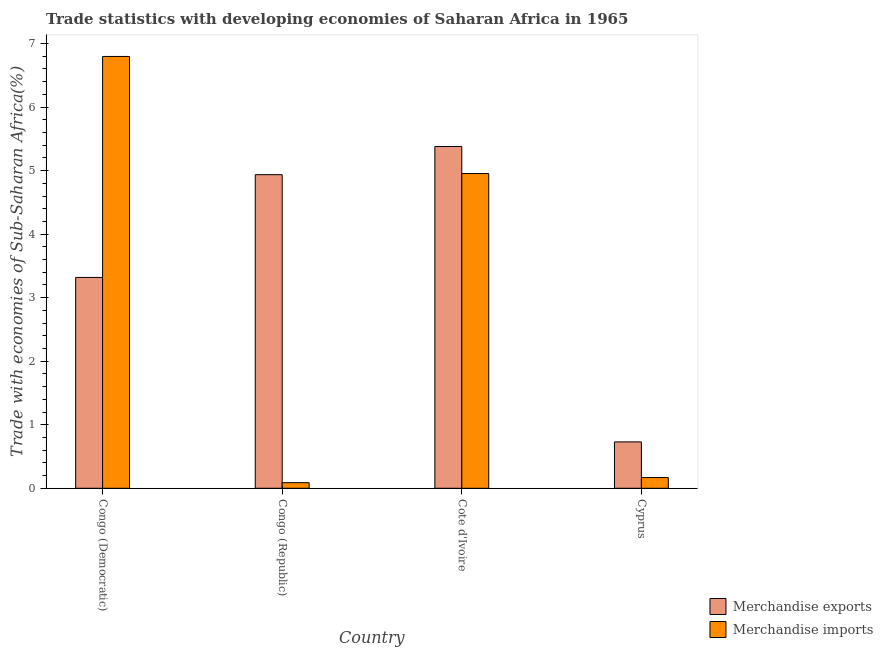How many groups of bars are there?
Offer a terse response. 4. Are the number of bars per tick equal to the number of legend labels?
Make the answer very short. Yes. Are the number of bars on each tick of the X-axis equal?
Make the answer very short. Yes. What is the label of the 1st group of bars from the left?
Provide a succinct answer. Congo (Democratic). What is the merchandise exports in Cote d'Ivoire?
Give a very brief answer. 5.38. Across all countries, what is the maximum merchandise imports?
Provide a succinct answer. 6.8. Across all countries, what is the minimum merchandise exports?
Provide a succinct answer. 0.73. In which country was the merchandise exports maximum?
Offer a very short reply. Cote d'Ivoire. In which country was the merchandise imports minimum?
Make the answer very short. Congo (Republic). What is the total merchandise imports in the graph?
Your answer should be very brief. 12.01. What is the difference between the merchandise exports in Congo (Democratic) and that in Cyprus?
Offer a very short reply. 2.59. What is the difference between the merchandise imports in Congo (Republic) and the merchandise exports in Congo (Democratic)?
Provide a succinct answer. -3.23. What is the average merchandise exports per country?
Make the answer very short. 3.59. What is the difference between the merchandise imports and merchandise exports in Cote d'Ivoire?
Your answer should be compact. -0.43. In how many countries, is the merchandise imports greater than 3.4 %?
Provide a short and direct response. 2. What is the ratio of the merchandise exports in Cote d'Ivoire to that in Cyprus?
Your answer should be very brief. 7.37. Is the difference between the merchandise exports in Cote d'Ivoire and Cyprus greater than the difference between the merchandise imports in Cote d'Ivoire and Cyprus?
Your response must be concise. No. What is the difference between the highest and the second highest merchandise imports?
Provide a succinct answer. 1.84. What is the difference between the highest and the lowest merchandise exports?
Offer a terse response. 4.65. Is the sum of the merchandise exports in Cote d'Ivoire and Cyprus greater than the maximum merchandise imports across all countries?
Your answer should be very brief. No. What does the 1st bar from the right in Cote d'Ivoire represents?
Give a very brief answer. Merchandise imports. How many countries are there in the graph?
Your answer should be very brief. 4. Are the values on the major ticks of Y-axis written in scientific E-notation?
Ensure brevity in your answer.  No. Where does the legend appear in the graph?
Your answer should be compact. Bottom right. What is the title of the graph?
Keep it short and to the point. Trade statistics with developing economies of Saharan Africa in 1965. What is the label or title of the X-axis?
Your answer should be compact. Country. What is the label or title of the Y-axis?
Make the answer very short. Trade with economies of Sub-Saharan Africa(%). What is the Trade with economies of Sub-Saharan Africa(%) in Merchandise exports in Congo (Democratic)?
Ensure brevity in your answer.  3.32. What is the Trade with economies of Sub-Saharan Africa(%) in Merchandise imports in Congo (Democratic)?
Offer a terse response. 6.8. What is the Trade with economies of Sub-Saharan Africa(%) of Merchandise exports in Congo (Republic)?
Give a very brief answer. 4.94. What is the Trade with economies of Sub-Saharan Africa(%) in Merchandise imports in Congo (Republic)?
Provide a succinct answer. 0.09. What is the Trade with economies of Sub-Saharan Africa(%) of Merchandise exports in Cote d'Ivoire?
Your answer should be compact. 5.38. What is the Trade with economies of Sub-Saharan Africa(%) in Merchandise imports in Cote d'Ivoire?
Keep it short and to the point. 4.95. What is the Trade with economies of Sub-Saharan Africa(%) of Merchandise exports in Cyprus?
Offer a terse response. 0.73. What is the Trade with economies of Sub-Saharan Africa(%) in Merchandise imports in Cyprus?
Ensure brevity in your answer.  0.17. Across all countries, what is the maximum Trade with economies of Sub-Saharan Africa(%) in Merchandise exports?
Ensure brevity in your answer.  5.38. Across all countries, what is the maximum Trade with economies of Sub-Saharan Africa(%) of Merchandise imports?
Your answer should be compact. 6.8. Across all countries, what is the minimum Trade with economies of Sub-Saharan Africa(%) in Merchandise exports?
Give a very brief answer. 0.73. Across all countries, what is the minimum Trade with economies of Sub-Saharan Africa(%) in Merchandise imports?
Ensure brevity in your answer.  0.09. What is the total Trade with economies of Sub-Saharan Africa(%) of Merchandise exports in the graph?
Your answer should be compact. 14.36. What is the total Trade with economies of Sub-Saharan Africa(%) in Merchandise imports in the graph?
Your response must be concise. 12.01. What is the difference between the Trade with economies of Sub-Saharan Africa(%) in Merchandise exports in Congo (Democratic) and that in Congo (Republic)?
Your answer should be very brief. -1.62. What is the difference between the Trade with economies of Sub-Saharan Africa(%) of Merchandise imports in Congo (Democratic) and that in Congo (Republic)?
Your answer should be very brief. 6.71. What is the difference between the Trade with economies of Sub-Saharan Africa(%) of Merchandise exports in Congo (Democratic) and that in Cote d'Ivoire?
Provide a succinct answer. -2.06. What is the difference between the Trade with economies of Sub-Saharan Africa(%) of Merchandise imports in Congo (Democratic) and that in Cote d'Ivoire?
Your answer should be compact. 1.84. What is the difference between the Trade with economies of Sub-Saharan Africa(%) in Merchandise exports in Congo (Democratic) and that in Cyprus?
Your answer should be very brief. 2.59. What is the difference between the Trade with economies of Sub-Saharan Africa(%) in Merchandise imports in Congo (Democratic) and that in Cyprus?
Your response must be concise. 6.63. What is the difference between the Trade with economies of Sub-Saharan Africa(%) of Merchandise exports in Congo (Republic) and that in Cote d'Ivoire?
Give a very brief answer. -0.44. What is the difference between the Trade with economies of Sub-Saharan Africa(%) in Merchandise imports in Congo (Republic) and that in Cote d'Ivoire?
Provide a succinct answer. -4.87. What is the difference between the Trade with economies of Sub-Saharan Africa(%) in Merchandise exports in Congo (Republic) and that in Cyprus?
Ensure brevity in your answer.  4.21. What is the difference between the Trade with economies of Sub-Saharan Africa(%) in Merchandise imports in Congo (Republic) and that in Cyprus?
Give a very brief answer. -0.08. What is the difference between the Trade with economies of Sub-Saharan Africa(%) in Merchandise exports in Cote d'Ivoire and that in Cyprus?
Your response must be concise. 4.65. What is the difference between the Trade with economies of Sub-Saharan Africa(%) in Merchandise imports in Cote d'Ivoire and that in Cyprus?
Make the answer very short. 4.79. What is the difference between the Trade with economies of Sub-Saharan Africa(%) of Merchandise exports in Congo (Democratic) and the Trade with economies of Sub-Saharan Africa(%) of Merchandise imports in Congo (Republic)?
Make the answer very short. 3.23. What is the difference between the Trade with economies of Sub-Saharan Africa(%) in Merchandise exports in Congo (Democratic) and the Trade with economies of Sub-Saharan Africa(%) in Merchandise imports in Cote d'Ivoire?
Your answer should be compact. -1.64. What is the difference between the Trade with economies of Sub-Saharan Africa(%) in Merchandise exports in Congo (Democratic) and the Trade with economies of Sub-Saharan Africa(%) in Merchandise imports in Cyprus?
Provide a short and direct response. 3.15. What is the difference between the Trade with economies of Sub-Saharan Africa(%) in Merchandise exports in Congo (Republic) and the Trade with economies of Sub-Saharan Africa(%) in Merchandise imports in Cote d'Ivoire?
Keep it short and to the point. -0.02. What is the difference between the Trade with economies of Sub-Saharan Africa(%) in Merchandise exports in Congo (Republic) and the Trade with economies of Sub-Saharan Africa(%) in Merchandise imports in Cyprus?
Provide a short and direct response. 4.77. What is the difference between the Trade with economies of Sub-Saharan Africa(%) in Merchandise exports in Cote d'Ivoire and the Trade with economies of Sub-Saharan Africa(%) in Merchandise imports in Cyprus?
Provide a short and direct response. 5.21. What is the average Trade with economies of Sub-Saharan Africa(%) in Merchandise exports per country?
Give a very brief answer. 3.59. What is the average Trade with economies of Sub-Saharan Africa(%) in Merchandise imports per country?
Provide a succinct answer. 3. What is the difference between the Trade with economies of Sub-Saharan Africa(%) of Merchandise exports and Trade with economies of Sub-Saharan Africa(%) of Merchandise imports in Congo (Democratic)?
Offer a terse response. -3.48. What is the difference between the Trade with economies of Sub-Saharan Africa(%) of Merchandise exports and Trade with economies of Sub-Saharan Africa(%) of Merchandise imports in Congo (Republic)?
Make the answer very short. 4.85. What is the difference between the Trade with economies of Sub-Saharan Africa(%) of Merchandise exports and Trade with economies of Sub-Saharan Africa(%) of Merchandise imports in Cote d'Ivoire?
Your response must be concise. 0.43. What is the difference between the Trade with economies of Sub-Saharan Africa(%) in Merchandise exports and Trade with economies of Sub-Saharan Africa(%) in Merchandise imports in Cyprus?
Your answer should be compact. 0.56. What is the ratio of the Trade with economies of Sub-Saharan Africa(%) of Merchandise exports in Congo (Democratic) to that in Congo (Republic)?
Ensure brevity in your answer.  0.67. What is the ratio of the Trade with economies of Sub-Saharan Africa(%) in Merchandise imports in Congo (Democratic) to that in Congo (Republic)?
Make the answer very short. 76.81. What is the ratio of the Trade with economies of Sub-Saharan Africa(%) of Merchandise exports in Congo (Democratic) to that in Cote d'Ivoire?
Provide a short and direct response. 0.62. What is the ratio of the Trade with economies of Sub-Saharan Africa(%) in Merchandise imports in Congo (Democratic) to that in Cote d'Ivoire?
Keep it short and to the point. 1.37. What is the ratio of the Trade with economies of Sub-Saharan Africa(%) in Merchandise exports in Congo (Democratic) to that in Cyprus?
Offer a terse response. 4.55. What is the ratio of the Trade with economies of Sub-Saharan Africa(%) of Merchandise imports in Congo (Democratic) to that in Cyprus?
Your answer should be compact. 40.35. What is the ratio of the Trade with economies of Sub-Saharan Africa(%) of Merchandise exports in Congo (Republic) to that in Cote d'Ivoire?
Your response must be concise. 0.92. What is the ratio of the Trade with economies of Sub-Saharan Africa(%) of Merchandise imports in Congo (Republic) to that in Cote d'Ivoire?
Provide a succinct answer. 0.02. What is the ratio of the Trade with economies of Sub-Saharan Africa(%) in Merchandise exports in Congo (Republic) to that in Cyprus?
Offer a very short reply. 6.76. What is the ratio of the Trade with economies of Sub-Saharan Africa(%) of Merchandise imports in Congo (Republic) to that in Cyprus?
Offer a terse response. 0.53. What is the ratio of the Trade with economies of Sub-Saharan Africa(%) in Merchandise exports in Cote d'Ivoire to that in Cyprus?
Provide a short and direct response. 7.37. What is the ratio of the Trade with economies of Sub-Saharan Africa(%) of Merchandise imports in Cote d'Ivoire to that in Cyprus?
Provide a succinct answer. 29.41. What is the difference between the highest and the second highest Trade with economies of Sub-Saharan Africa(%) of Merchandise exports?
Your answer should be very brief. 0.44. What is the difference between the highest and the second highest Trade with economies of Sub-Saharan Africa(%) of Merchandise imports?
Give a very brief answer. 1.84. What is the difference between the highest and the lowest Trade with economies of Sub-Saharan Africa(%) of Merchandise exports?
Give a very brief answer. 4.65. What is the difference between the highest and the lowest Trade with economies of Sub-Saharan Africa(%) of Merchandise imports?
Provide a succinct answer. 6.71. 